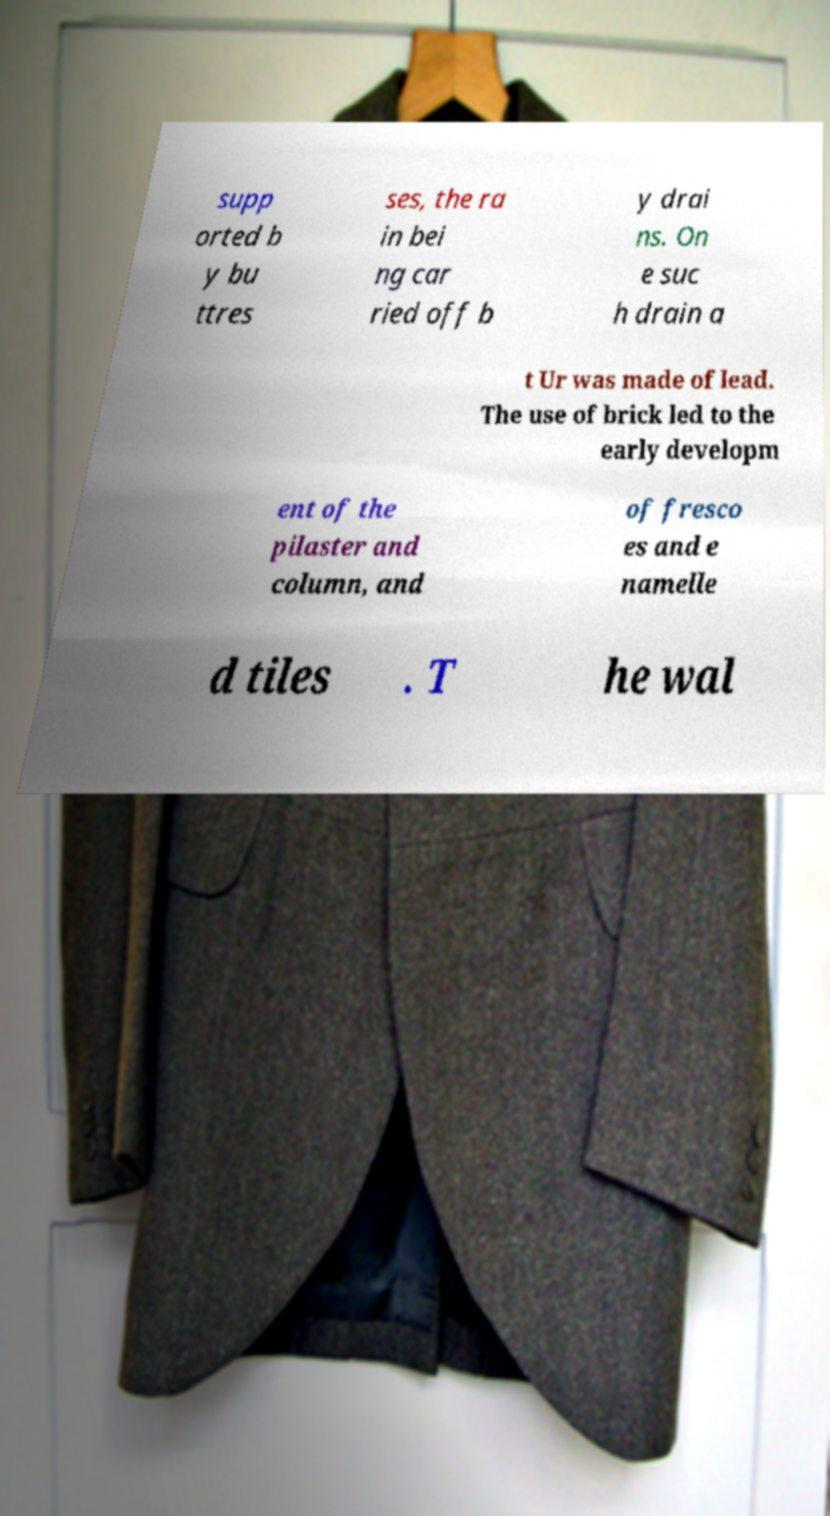Please identify and transcribe the text found in this image. supp orted b y bu ttres ses, the ra in bei ng car ried off b y drai ns. On e suc h drain a t Ur was made of lead. The use of brick led to the early developm ent of the pilaster and column, and of fresco es and e namelle d tiles . T he wal 